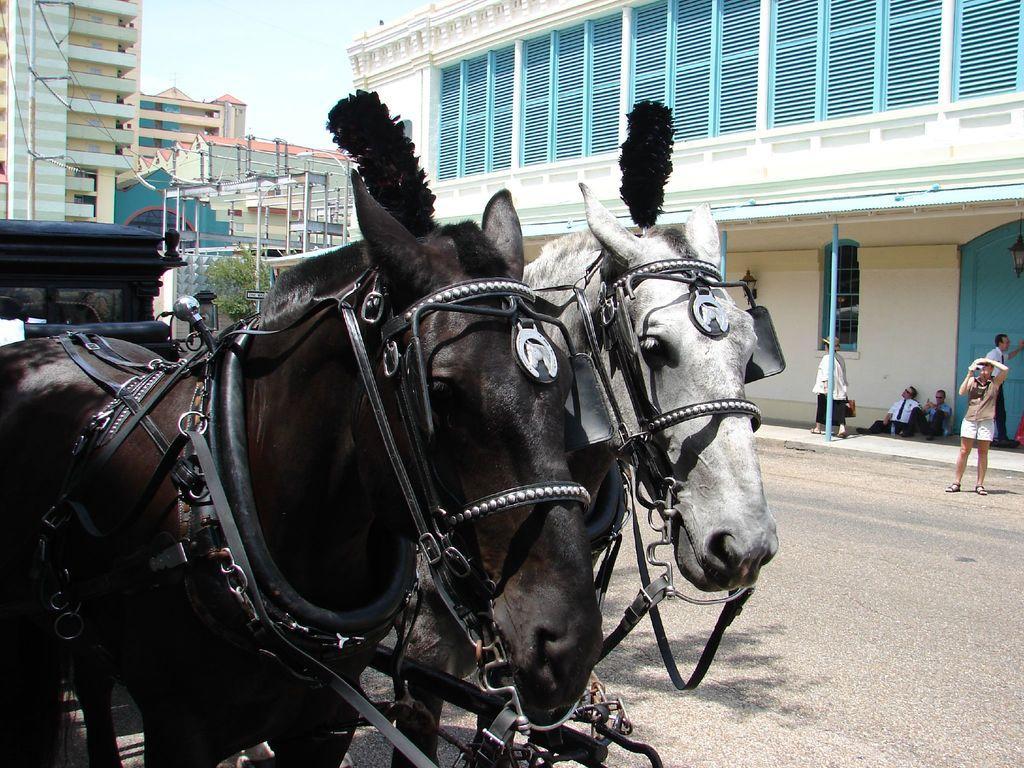In one or two sentences, can you explain what this image depicts? In the image there are two horses, black and white. There is a cart tied to them and beside the horses there are many other buildings and some people were residing under the shelter of the building and a woman is walking on the path, another person is taking the photo of the horses, in the background there is a sky. 